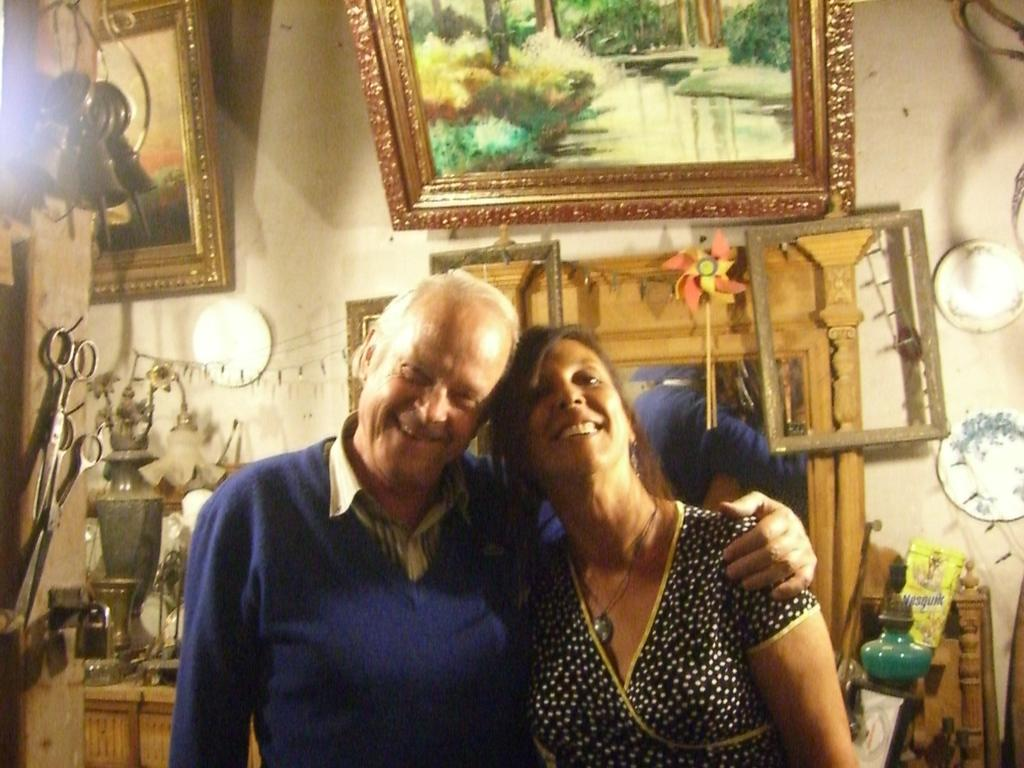How many people are present in the image? There are two people, a man and a woman, present in the image. What expressions do the man and woman have in the image? Both the man and the woman are smiling in the image. What can be seen in the background of the image? There is a wall, photo frames, scissors, and other objects in the background of the image. Can you describe the objects in the background of the image? The background of the image includes photo frames, scissors, and other unspecified objects. What type of dirt can be seen on the man's shoes in the image? There is no dirt visible on the man's shoes in the image. What type of brush is the woman using to clean the scissors in the image? There is no brush or cleaning activity depicted in the image. 